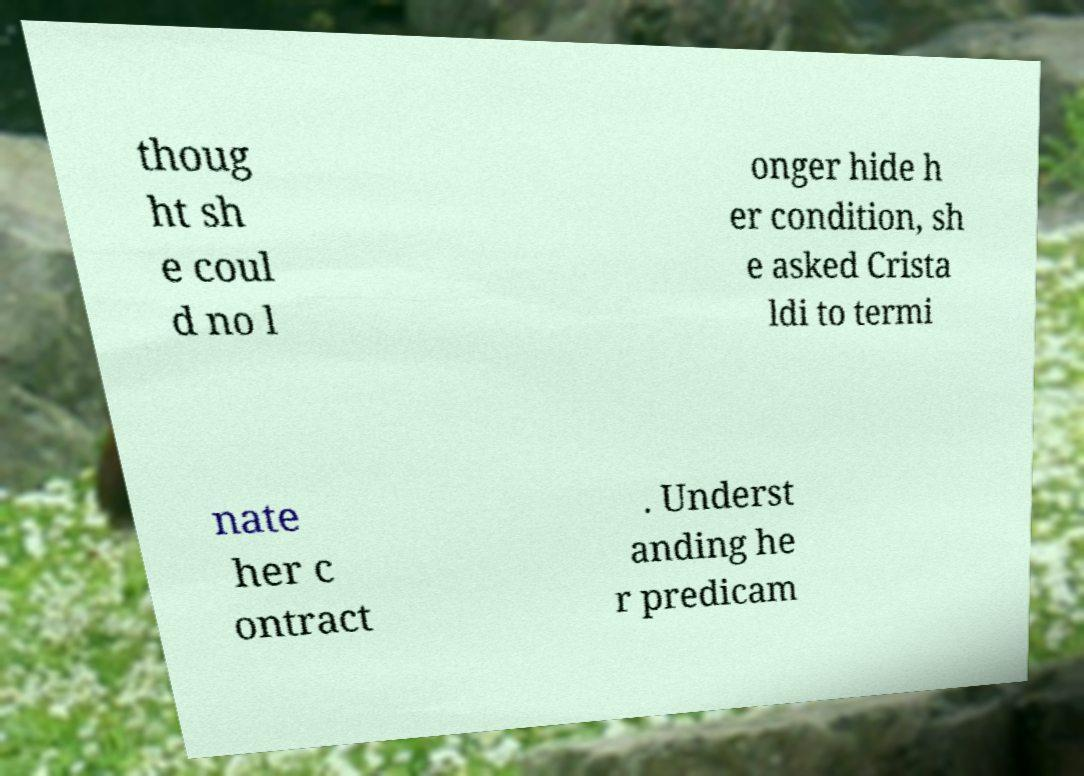For documentation purposes, I need the text within this image transcribed. Could you provide that? thoug ht sh e coul d no l onger hide h er condition, sh e asked Crista ldi to termi nate her c ontract . Underst anding he r predicam 